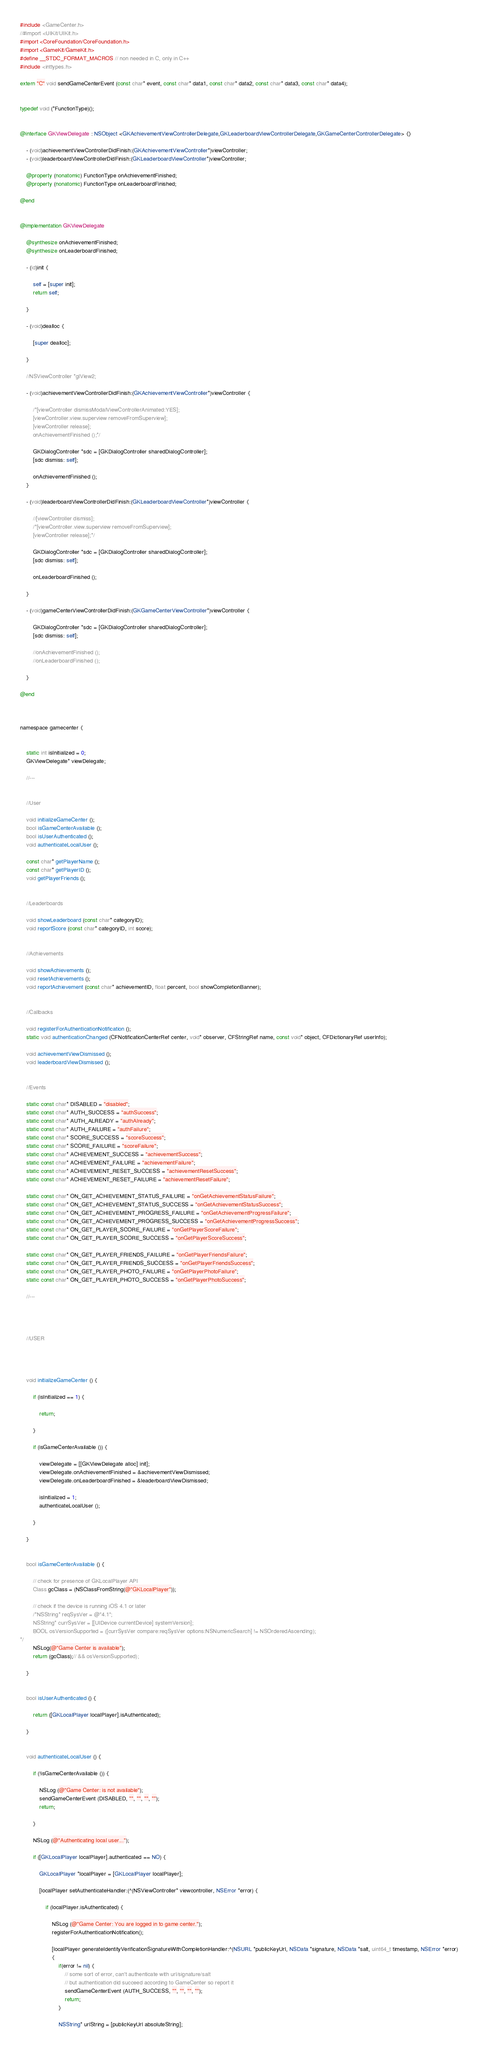Convert code to text. <code><loc_0><loc_0><loc_500><loc_500><_ObjectiveC_>#include <GameCenter.h>
//#import <UIKit/UIKit.h>
#import <CoreFoundation/CoreFoundation.h>
#import <GameKit/GameKit.h>
#define __STDC_FORMAT_MACROS // non needed in C, only in C++
#include <inttypes.h>

extern "C" void sendGameCenterEvent (const char* event, const char* data1, const char* data2, const char* data3, const char* data4);


typedef void (*FunctionType)();


@interface GKViewDelegate : NSObject <GKAchievementViewControllerDelegate,GKLeaderboardViewControllerDelegate,GKGameCenterControllerDelegate> {}
	
	- (void)achievementViewControllerDidFinish:(GKAchievementViewController*)viewController;
	- (void)leaderboardViewControllerDidFinish:(GKLeaderboardViewController*)viewController;
	
	@property (nonatomic) FunctionType onAchievementFinished;
	@property (nonatomic) FunctionType onLeaderboardFinished;
	
@end


@implementation GKViewDelegate
	
	@synthesize onAchievementFinished;
	@synthesize onLeaderboardFinished;
	
	- (id)init {
		
		self = [super init];
		return self;
		
	}
	
	- (void)dealloc {
		
		[super dealloc];
		
	}
	
	//NSViewController *glView2;
	
	- (void)achievementViewControllerDidFinish:(GKAchievementViewController*)viewController {
		
		/*[viewController dismissModalViewControllerAnimated:YES];
		[viewController.view.superview removeFromSuperview];
		[viewController release];
		onAchievementFinished ();*/

		GKDialogController *sdc = [GKDialogController sharedDialogController];
		[sdc dismiss: self];
		
		onAchievementFinished ();
	}
	
	- (void)leaderboardViewControllerDidFinish:(GKLeaderboardViewController*)viewController {
		
		//[viewController dismiss];
		/*[viewController.view.superview removeFromSuperview];
		[viewController release];*/

		GKDialogController *sdc = [GKDialogController sharedDialogController];
		[sdc dismiss: self];

		onLeaderboardFinished ();
		
	}

	- (void)gameCenterViewControllerDidFinish:(GKGameCenterViewController*)viewController {
		
		GKDialogController *sdc = [GKDialogController sharedDialogController];
		[sdc dismiss: self];

		//onAchievementFinished ();
		//onLeaderboardFinished ();
		
	}
	
@end



namespace gamecenter {
	
	
	static int isInitialized = 0;
	GKViewDelegate* viewDelegate;
	
	//---
	
	
	//User
	
	void initializeGameCenter ();
	bool isGameCenterAvailable ();
	bool isUserAuthenticated ();
	void authenticateLocalUser ();
	
	const char* getPlayerName ();
	const char* getPlayerID ();
	void getPlayerFriends ();
	
	
	//Leaderboards
	
	void showLeaderboard (const char* categoryID);
	void reportScore (const char* categoryID, int score);
	
	
	//Achievements
	
	void showAchievements ();
	void resetAchievements ();
	void reportAchievement (const char* achievementID, float percent, bool showCompletionBanner);
	
	
	//Callbacks
	
	void registerForAuthenticationNotification ();
	static void authenticationChanged (CFNotificationCenterRef center, void* observer, CFStringRef name, const void* object, CFDictionaryRef userInfo);
	
	void achievementViewDismissed ();
	void leaderboardViewDismissed ();
	
	
	//Events
	
	static const char* DISABLED = "disabled";
	static const char* AUTH_SUCCESS = "authSuccess";
	static const char* AUTH_ALREADY = "authAlready";
	static const char* AUTH_FAILURE = "authFailure";
	static const char* SCORE_SUCCESS = "scoreSuccess";
	static const char* SCORE_FAILURE = "scoreFailure";
	static const char* ACHIEVEMENT_SUCCESS = "achievementSuccess";
	static const char* ACHIEVEMENT_FAILURE = "achievementFailure";
	static const char* ACHIEVEMENT_RESET_SUCCESS = "achievementResetSuccess";
	static const char* ACHIEVEMENT_RESET_FAILURE = "achievementResetFailure";

	static const char* ON_GET_ACHIEVEMENT_STATUS_FAILURE = "onGetAchievementStatusFailure";
	static const char* ON_GET_ACHIEVEMENT_STATUS_SUCCESS = "onGetAchievementStatusSuccess";
	static const char* ON_GET_ACHIEVEMENT_PROGRESS_FAILURE = "onGetAchievementProgressFailure"; 
	static const char* ON_GET_ACHIEVEMENT_PROGRESS_SUCCESS = "onGetAchievementProgressSuccess";
	static const char* ON_GET_PLAYER_SCORE_FAILURE = "onGetPlayerScoreFailure";
	static const char* ON_GET_PLAYER_SCORE_SUCCESS = "onGetPlayerScoreSuccess";

	static const char* ON_GET_PLAYER_FRIENDS_FAILURE = "onGetPlayerFriendsFailure";
	static const char* ON_GET_PLAYER_FRIENDS_SUCCESS = "onGetPlayerFriendsSuccess";
	static const char* ON_GET_PLAYER_PHOTO_FAILURE = "onGetPlayerPhotoFailure";
	static const char* ON_GET_PLAYER_PHOTO_SUCCESS = "onGetPlayerPhotoSuccess";
	
	//---
	
	
	
	
	//USER
	
	
	
	
	void initializeGameCenter () {
		
		if (isInitialized == 1) {
			
			return;
			
		}
		
		if (isGameCenterAvailable ()) {
			
			viewDelegate = [[GKViewDelegate alloc] init];
			viewDelegate.onAchievementFinished = &achievementViewDismissed;
			viewDelegate.onLeaderboardFinished = &leaderboardViewDismissed;
			
			isInitialized = 1;
			authenticateLocalUser ();
			
		}
		
	}
	
	
	bool isGameCenterAvailable () {
		
		// check for presence of GKLocalPlayer API
		Class gcClass = (NSClassFromString(@"GKLocalPlayer"));
		
		// check if the device is running iOS 4.1 or later  
		/*NSString* reqSysVer = @"4.1";   
		NSString* currSysVer = [[UIDevice currentDevice] systemVersion];   
		BOOL osVersionSupported = ([currSysVer compare:reqSysVer options:NSNumericSearch] != NSOrderedAscending);   
*/
		NSLog(@"Game Center is available");
		return (gcClass);// && osVersionSupported);
		
	}
	
	
	bool isUserAuthenticated () {
		
		return ([GKLocalPlayer localPlayer].isAuthenticated);
		
	}
	
	
	void authenticateLocalUser () {
		
		if (!isGameCenterAvailable ()) {
			
			NSLog (@"Game Center: is not available");
			sendGameCenterEvent (DISABLED, "", "", "", "");
			return;
			
		}
		
		NSLog (@"Authenticating local user...");
		
		if ([GKLocalPlayer localPlayer].authenticated == NO) {
			
			GKLocalPlayer *localPlayer = [GKLocalPlayer localPlayer];

			[localPlayer setAuthenticateHandler:(^(NSViewController* viewcontroller, NSError *error) {
				
				if (localPlayer.isAuthenticated) {
					
					NSLog (@"Game Center: You are logged in to game center.");
					registerForAuthenticationNotification();

					[localPlayer generateIdentityVerificationSignatureWithCompletionHandler:^(NSURL *publicKeyUrl, NSData *signature, NSData *salt, uint64_t timestamp, NSError *error)
					{
						if(error != nil) {
						    // some sort of error, can't authenticate with url/signature/salt
						    // but authentication did succeed according to GameCenter so report it
						    sendGameCenterEvent (AUTH_SUCCESS, "", "", "", "");
						    return;
						}

						NSString* urlString = [publicKeyUrl absoluteString];
</code> 